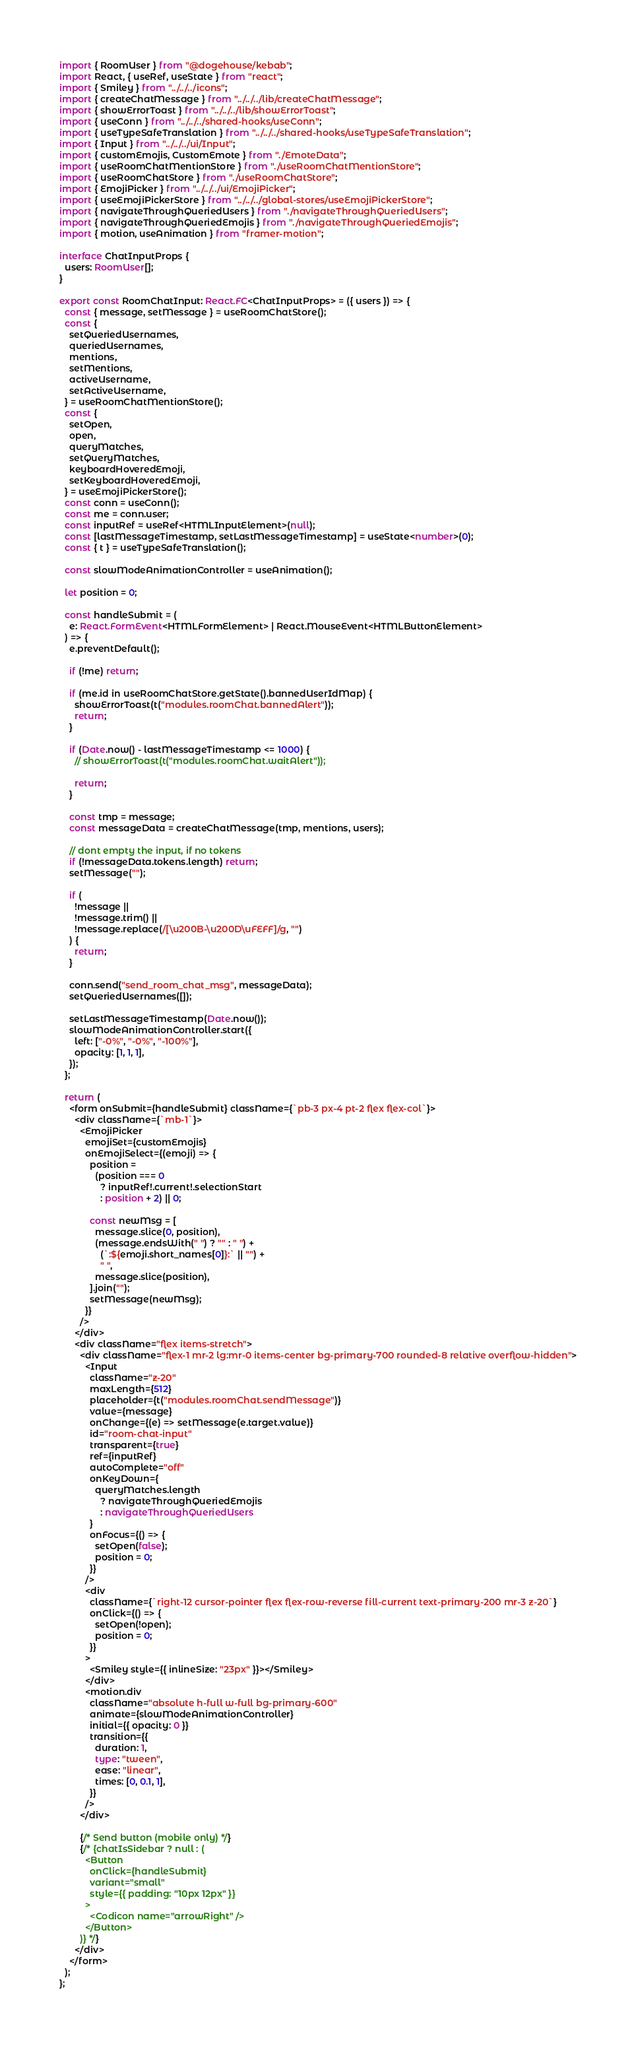Convert code to text. <code><loc_0><loc_0><loc_500><loc_500><_TypeScript_>import { RoomUser } from "@dogehouse/kebab";
import React, { useRef, useState } from "react";
import { Smiley } from "../../../icons";
import { createChatMessage } from "../../../lib/createChatMessage";
import { showErrorToast } from "../../../lib/showErrorToast";
import { useConn } from "../../../shared-hooks/useConn";
import { useTypeSafeTranslation } from "../../../shared-hooks/useTypeSafeTranslation";
import { Input } from "../../../ui/Input";
import { customEmojis, CustomEmote } from "./EmoteData";
import { useRoomChatMentionStore } from "./useRoomChatMentionStore";
import { useRoomChatStore } from "./useRoomChatStore";
import { EmojiPicker } from "../../../ui/EmojiPicker";
import { useEmojiPickerStore } from "../../../global-stores/useEmojiPickerStore";
import { navigateThroughQueriedUsers } from "./navigateThroughQueriedUsers";
import { navigateThroughQueriedEmojis } from "./navigateThroughQueriedEmojis";
import { motion, useAnimation } from "framer-motion";

interface ChatInputProps {
  users: RoomUser[];
}

export const RoomChatInput: React.FC<ChatInputProps> = ({ users }) => {
  const { message, setMessage } = useRoomChatStore();
  const {
    setQueriedUsernames,
    queriedUsernames,
    mentions,
    setMentions,
    activeUsername,
    setActiveUsername,
  } = useRoomChatMentionStore();
  const {
    setOpen,
    open,
    queryMatches,
    setQueryMatches,
    keyboardHoveredEmoji,
    setKeyboardHoveredEmoji,
  } = useEmojiPickerStore();
  const conn = useConn();
  const me = conn.user;
  const inputRef = useRef<HTMLInputElement>(null);
  const [lastMessageTimestamp, setLastMessageTimestamp] = useState<number>(0);
  const { t } = useTypeSafeTranslation();

  const slowModeAnimationController = useAnimation();

  let position = 0;

  const handleSubmit = (
    e: React.FormEvent<HTMLFormElement> | React.MouseEvent<HTMLButtonElement>
  ) => {
    e.preventDefault();

    if (!me) return;

    if (me.id in useRoomChatStore.getState().bannedUserIdMap) {
      showErrorToast(t("modules.roomChat.bannedAlert"));
      return;
    }

    if (Date.now() - lastMessageTimestamp <= 1000) {
      // showErrorToast(t("modules.roomChat.waitAlert"));

      return;
    }

    const tmp = message;
    const messageData = createChatMessage(tmp, mentions, users);

    // dont empty the input, if no tokens
    if (!messageData.tokens.length) return;
    setMessage("");

    if (
      !message ||
      !message.trim() ||
      !message.replace(/[\u200B-\u200D\uFEFF]/g, "")
    ) {
      return;
    }

    conn.send("send_room_chat_msg", messageData);
    setQueriedUsernames([]);

    setLastMessageTimestamp(Date.now());
    slowModeAnimationController.start({
      left: ["-0%", "-0%", "-100%"],
      opacity: [1, 1, 1],
    });
  };

  return (
    <form onSubmit={handleSubmit} className={`pb-3 px-4 pt-2 flex flex-col`}>
      <div className={`mb-1`}>
        <EmojiPicker
          emojiSet={customEmojis}
          onEmojiSelect={(emoji) => {
            position =
              (position === 0
                ? inputRef!.current!.selectionStart
                : position + 2) || 0;

            const newMsg = [
              message.slice(0, position),
              (message.endsWith(" ") ? "" : " ") +
                (`:${emoji.short_names[0]}:` || "") +
                " ",
              message.slice(position),
            ].join("");
            setMessage(newMsg);
          }}
        />
      </div>
      <div className="flex items-stretch">
        <div className="flex-1 mr-2 lg:mr-0 items-center bg-primary-700 rounded-8 relative overflow-hidden">
          <Input
            className="z-20"
            maxLength={512}
            placeholder={t("modules.roomChat.sendMessage")}
            value={message}
            onChange={(e) => setMessage(e.target.value)}
            id="room-chat-input"
            transparent={true}
            ref={inputRef}
            autoComplete="off"
            onKeyDown={
              queryMatches.length
                ? navigateThroughQueriedEmojis
                : navigateThroughQueriedUsers
            }
            onFocus={() => {
              setOpen(false);
              position = 0;
            }}
          />
          <div
            className={`right-12 cursor-pointer flex flex-row-reverse fill-current text-primary-200 mr-3 z-20`}
            onClick={() => {
              setOpen(!open);
              position = 0;
            }}
          >
            <Smiley style={{ inlineSize: "23px" }}></Smiley>
          </div>
          <motion.div
            className="absolute h-full w-full bg-primary-600"
            animate={slowModeAnimationController}
            initial={{ opacity: 0 }}
            transition={{
              duration: 1,
              type: "tween",
              ease: "linear",
              times: [0, 0.1, 1],
            }}
          />
        </div>

        {/* Send button (mobile only) */}
        {/* {chatIsSidebar ? null : (
          <Button
            onClick={handleSubmit}
            variant="small"
            style={{ padding: "10px 12px" }}
          >
            <Codicon name="arrowRight" />
          </Button>
        )} */}
      </div>
    </form>
  );
};
</code> 